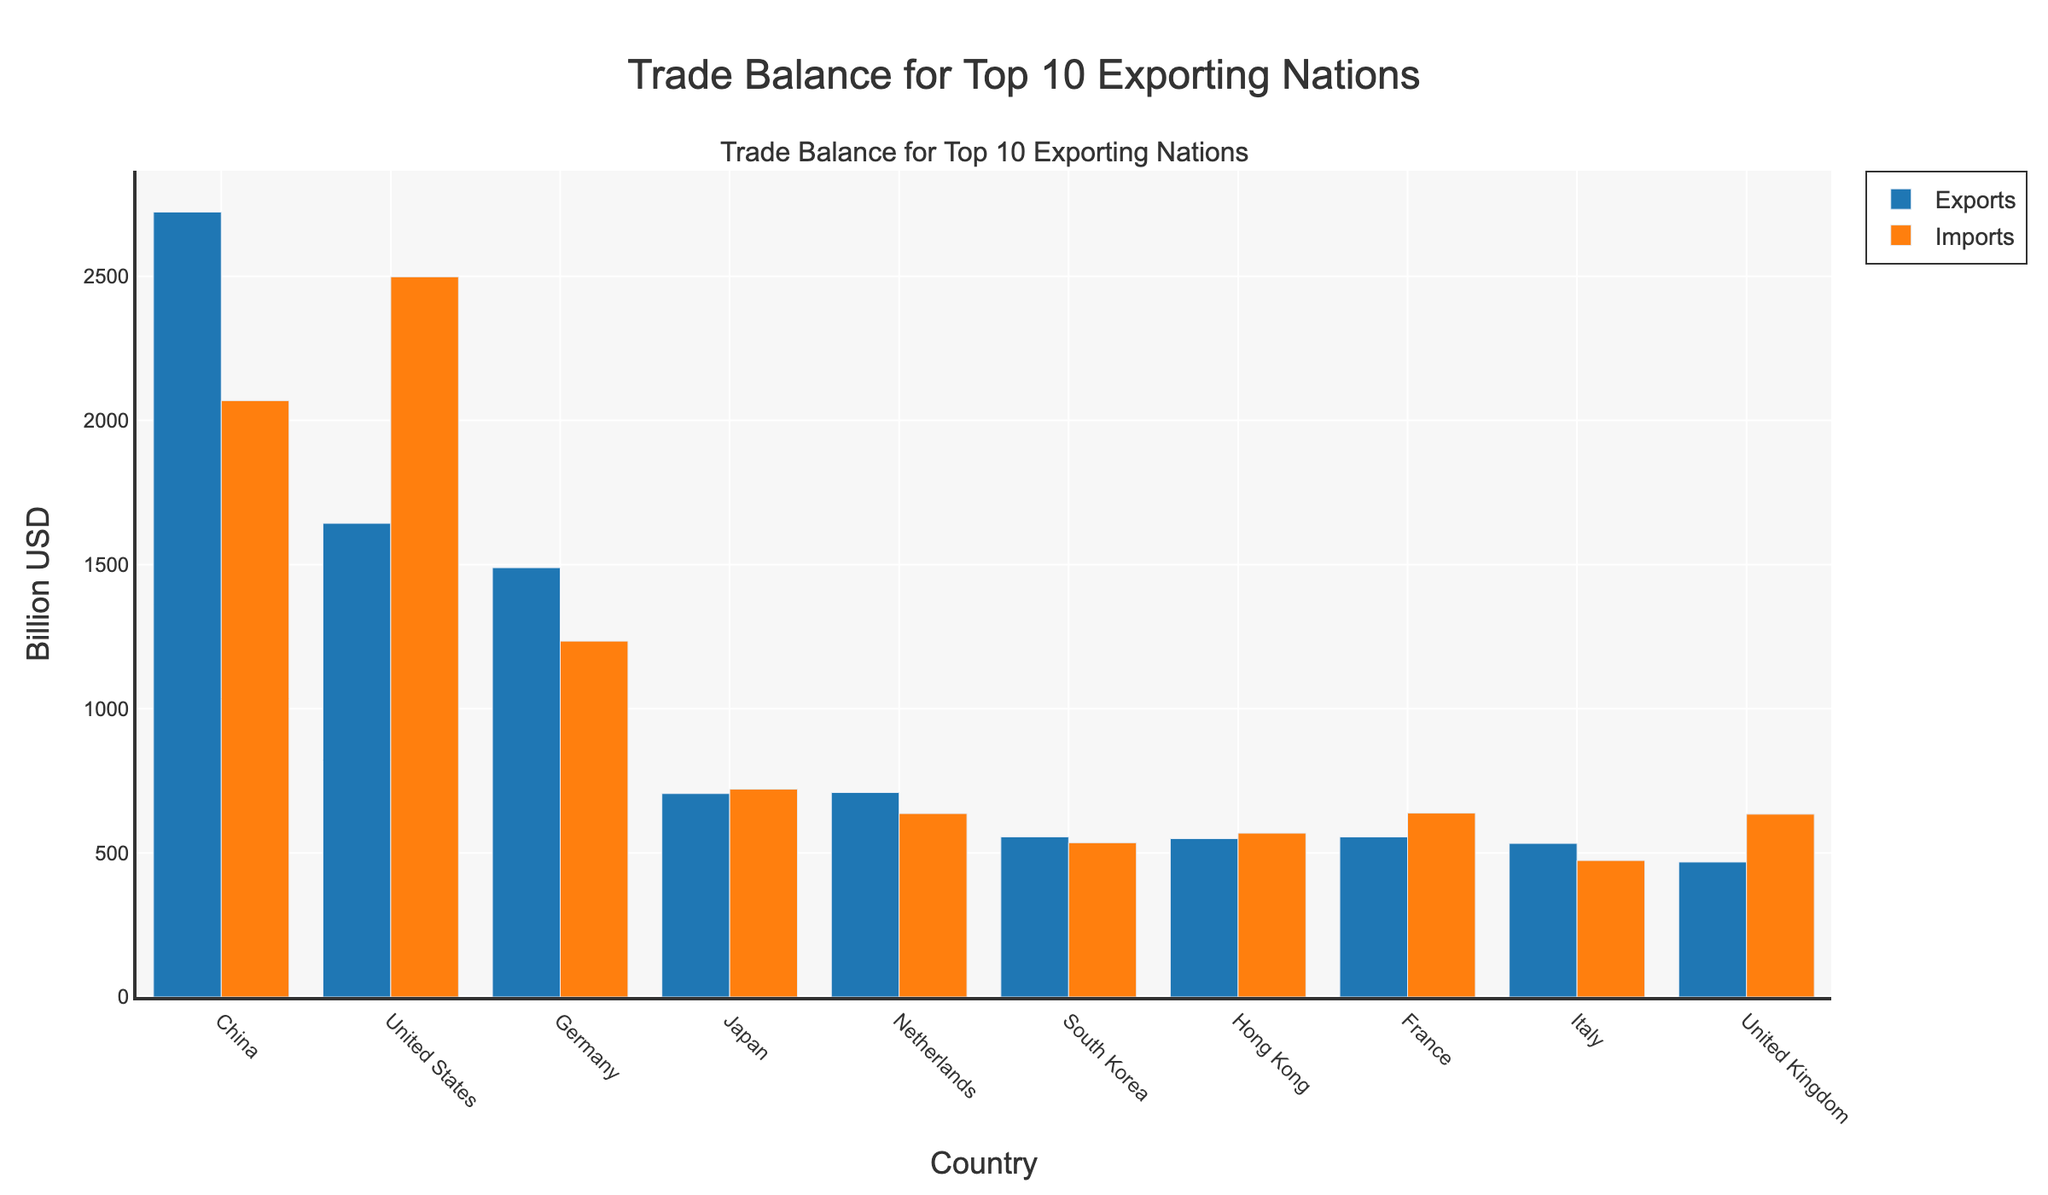What is the trade balance for Germany? The trade balance is calculated by subtracting imports from exports. For Germany, it is 1489.2 - 1234.5.
Answer: 254.7 Which country has the largest trade deficit? A trade deficit occurs when imports exceed exports. The country with the largest deficit is the United States with imports of 2498.5 billion USD and exports of 1643.2 billion USD.
Answer: United States How does the total export value compare between China and Japan? The total exports of China are 2723.1 billion USD, and the total exports of Japan are 705.6 billion USD. China exports significantly more than Japan.
Answer: China exports more For which country are the exports and imports nearly equal? By visually comparing the lengths of the bars, Japan's exports (705.6) and imports (720.9) are the closest to being equal.
Answer: Japan What is the overall trade balance for the United Kingdom? The trade balance is calculated by subtracting imports from exports. For the United Kingdom, it is 468.1 - 634.2, which results in a negative value indicating a trade deficit.
Answer: -166.1 Among the top 10 exporting nations, which country has the smallest trade surplus? A trade surplus occurs when exports exceed imports. Italy has the smallest trade surplus with exports of 532.7 billion USD and imports of 473.5 billion USD.
Answer: Italy What are the three countries with the highest export values? Observing the lengths of the export bars, the three countries with the highest export values are China (2723.1 billion USD), United States (1643.2 billion USD), and Germany (1489.2 billion USD).
Answer: China, United States, Germany Which country has the smallest difference between exports and imports? The smallest difference between exports and imports can be found by visually inspecting the bars for the closest heights. South Korea, with exports of 555.5 and imports of 535.2.
Answer: South Korea What is the total sum of imports for France and the Netherlands? The total imports for France (637.9) and the Netherlands (636.4) can be summed up: 637.9 + 636.4.
Answer: 1274.3 Compare the import values of Hong Kong and the United Kingdom. Which one is higher? The import value for Hong Kong is 568.4 billion USD, while for the United Kingdom, it is 634.2 billion USD. The United Kingdom has higher import values.
Answer: United Kingdom 